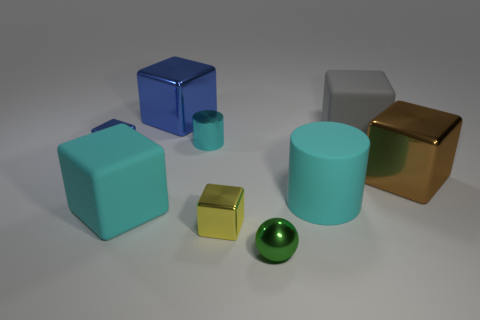The metallic ball has what size?
Provide a short and direct response. Small. There is a big thing that is the same color as the rubber cylinder; what shape is it?
Provide a succinct answer. Cube. How big is the shiny block behind the blue block on the left side of the large cyan cube?
Ensure brevity in your answer.  Large. How many spheres are either large cyan matte things or yellow shiny things?
Offer a very short reply. 0. There is a metal cylinder that is the same size as the green thing; what color is it?
Provide a succinct answer. Cyan. The small blue shiny object left of the big cyan rubber thing that is on the left side of the tiny yellow object is what shape?
Your answer should be very brief. Cube. There is a metallic cube in front of the cyan matte cube; does it have the same size as the brown shiny object?
Make the answer very short. No. What number of other objects are the same material as the tiny cyan thing?
Your response must be concise. 5. What number of gray things are either matte objects or cylinders?
Offer a very short reply. 1. The metal thing that is the same color as the rubber cylinder is what size?
Your answer should be very brief. Small. 